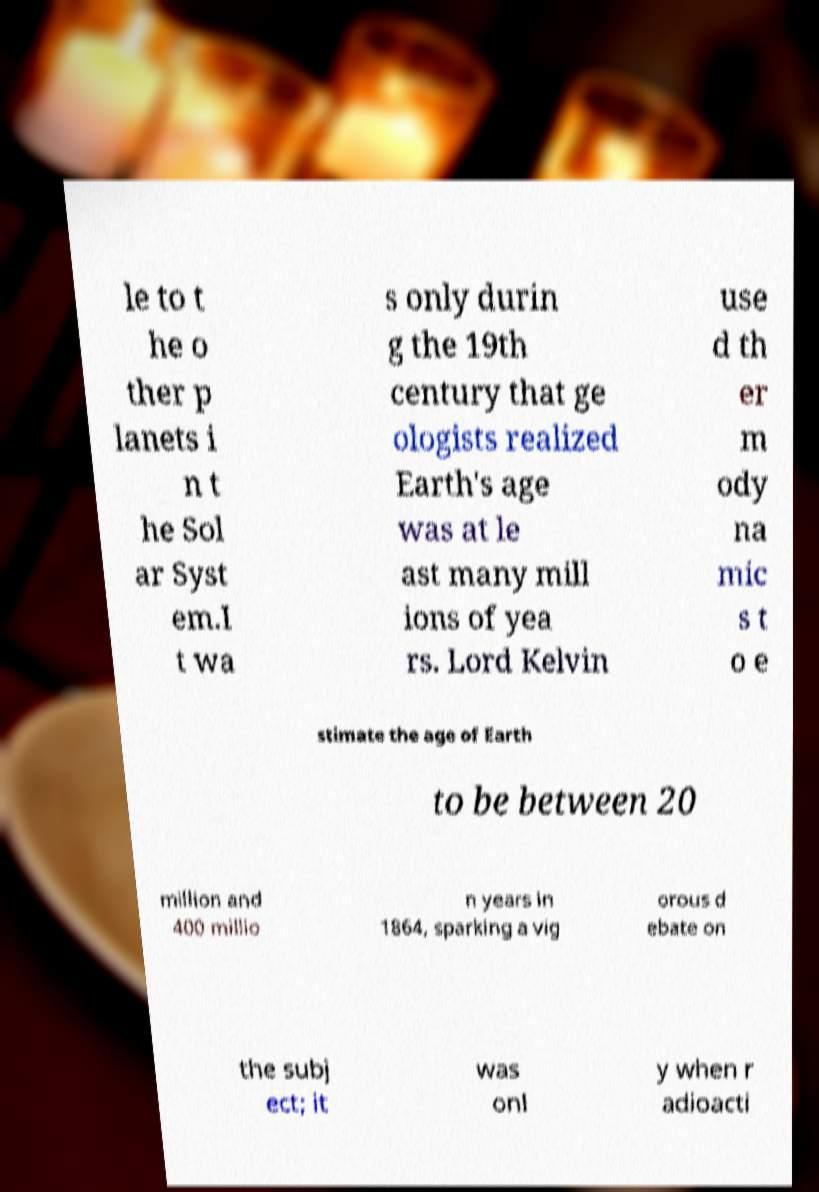For documentation purposes, I need the text within this image transcribed. Could you provide that? le to t he o ther p lanets i n t he Sol ar Syst em.I t wa s only durin g the 19th century that ge ologists realized Earth's age was at le ast many mill ions of yea rs. Lord Kelvin use d th er m ody na mic s t o e stimate the age of Earth to be between 20 million and 400 millio n years in 1864, sparking a vig orous d ebate on the subj ect; it was onl y when r adioacti 